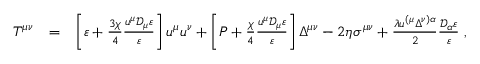Convert formula to latex. <formula><loc_0><loc_0><loc_500><loc_500>\begin{array} { r l r } { T ^ { \mu \nu } } & { = } & { \left [ \varepsilon + \frac { 3 \chi } { 4 } \frac { u ^ { \mu } \mathcal { D } _ { \mu } \varepsilon } { \varepsilon } \right ] u ^ { \mu } u ^ { \nu } + \left [ P + \frac { \chi } { 4 } \frac { u ^ { \mu } \mathcal { D } _ { \mu } \varepsilon } { \varepsilon } \right ] \Delta ^ { \mu \nu } - 2 \eta \sigma ^ { \mu \nu } + \frac { \lambda u ^ { ( \mu } \Delta ^ { \nu ) \alpha } } { 2 } \frac { \mathcal { D } _ { \alpha } \varepsilon } { \varepsilon } \, , } \end{array}</formula> 